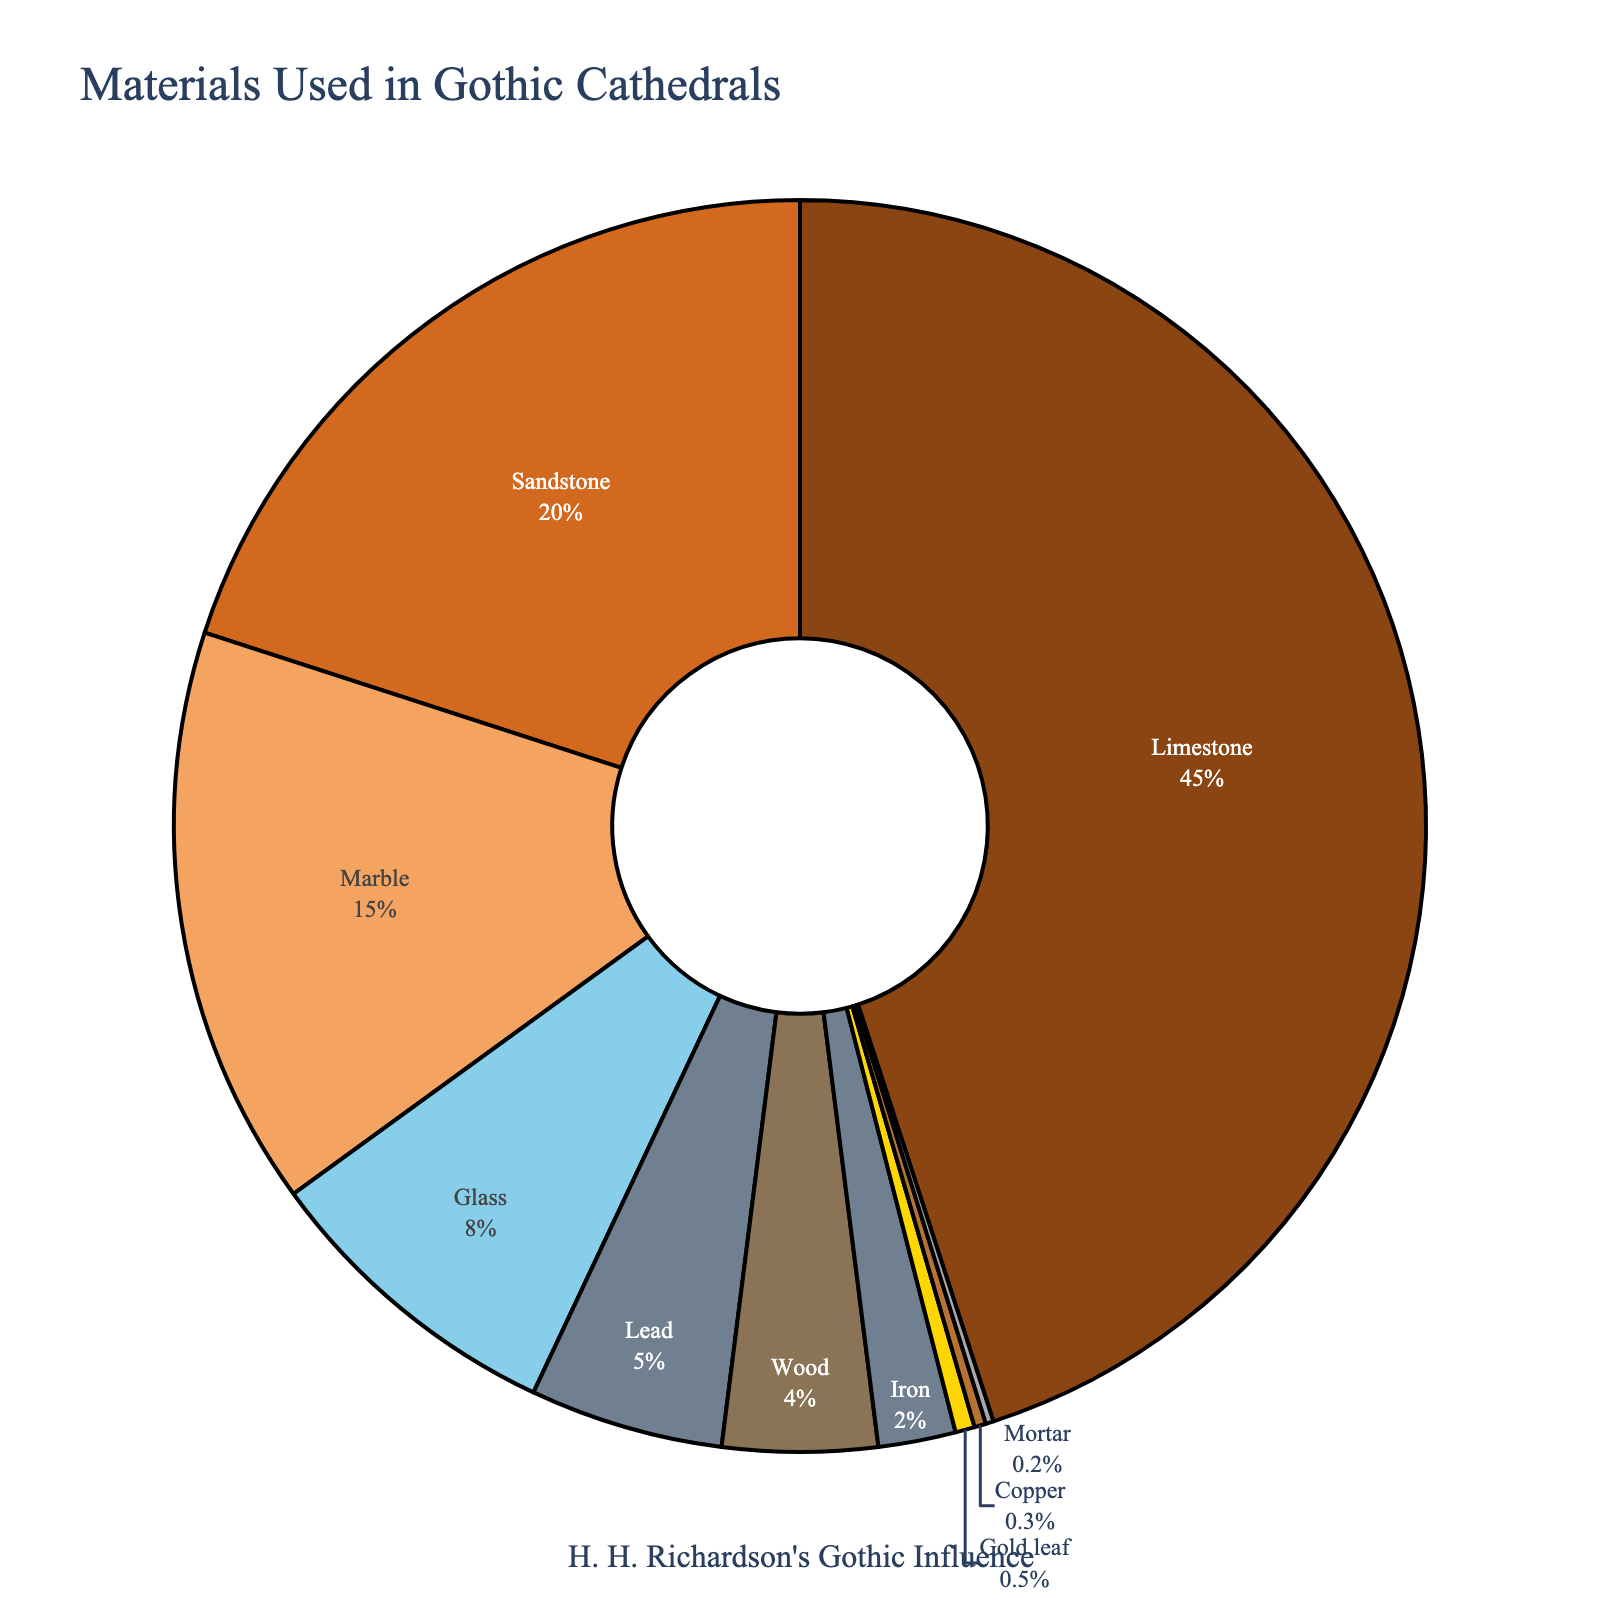What's the most used material in Gothic cathedrals according to the pie chart? The largest section of the pie chart represents the most used material. The section labeled "Limestone" is the largest, indicating it has the highest percentage.
Answer: Limestone What is the combined percentage of Marble and Glass used in Gothic cathedrals? According to the pie chart, Marble contributes 15% and Glass contributes 8%. Adding these together gives 15% + 8% = 23%.
Answer: 23% Which material is used more in Gothic cathedrals, Wood or Lead, and by how much? The pie chart shows that Lead is 5% and Wood is 4%. Subtracting the percentage of Wood from Lead gives 5% - 4% = 1%.
Answer: Lead by 1% List all materials that make up less than 5% of the total. From the pie chart, materials making up less than 5% are:
- Wood (4%)
- Iron (2%)
- Gold leaf (0.5%)
- Copper (0.3%)
- Mortar (0.2%)
Answer: Wood, Iron, Gold leaf, Copper, Mortar By how much does the use of Limestone exceed the combined use of Sandstone and Marble? Limestone is 45%, Sandstone is 20%, and Marble is 15%. The combined use of Sandstone and Marble is 20% + 15% = 35%. The difference is 45% - 35% = 10%.
Answer: 10% Which material contributes the smallest percentage and what is that percentage? The smallest section of the pie chart is labeled "Mortar," which indicates its percentage is the smallest at 0.2%.
Answer: Mortar at 0.2% What percentage of materials used are non-metallic (Limestone, Sandstone, Marble, Glass, Wood, Mortar)? Summing up the percentages of the non-metallic materials: Limestone (45%) + Sandstone (20%) + Marble (15%) + Glass (8%) + Wood (4%) + Mortar (0.2%) = 92.2%.
Answer: 92.2% How many times is Limestone used in comparison to Iron? Limestone is 45% and Iron is 2%. To find how many times Limestone is used compared to Iron, divide their percentages: 45% / 2% = 22.5 times.
Answer: 22.5 times 